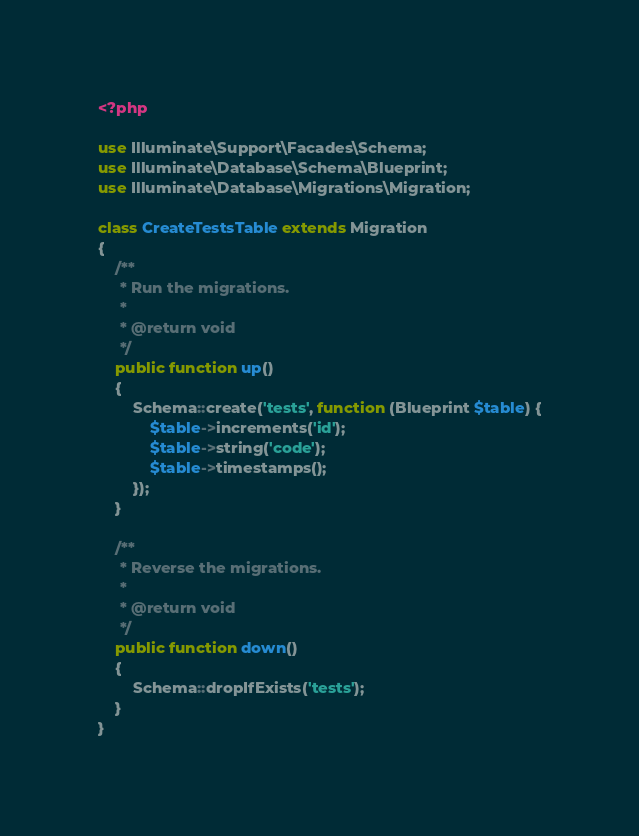<code> <loc_0><loc_0><loc_500><loc_500><_PHP_><?php

use Illuminate\Support\Facades\Schema;
use Illuminate\Database\Schema\Blueprint;
use Illuminate\Database\Migrations\Migration;

class CreateTestsTable extends Migration
{
    /**
     * Run the migrations.
     *
     * @return void
     */
    public function up()
    {
        Schema::create('tests', function (Blueprint $table) {
            $table->increments('id');
            $table->string('code');
            $table->timestamps();
        });
    }

    /**
     * Reverse the migrations.
     *
     * @return void
     */
    public function down()
    {
        Schema::dropIfExists('tests');
    }
}
</code> 